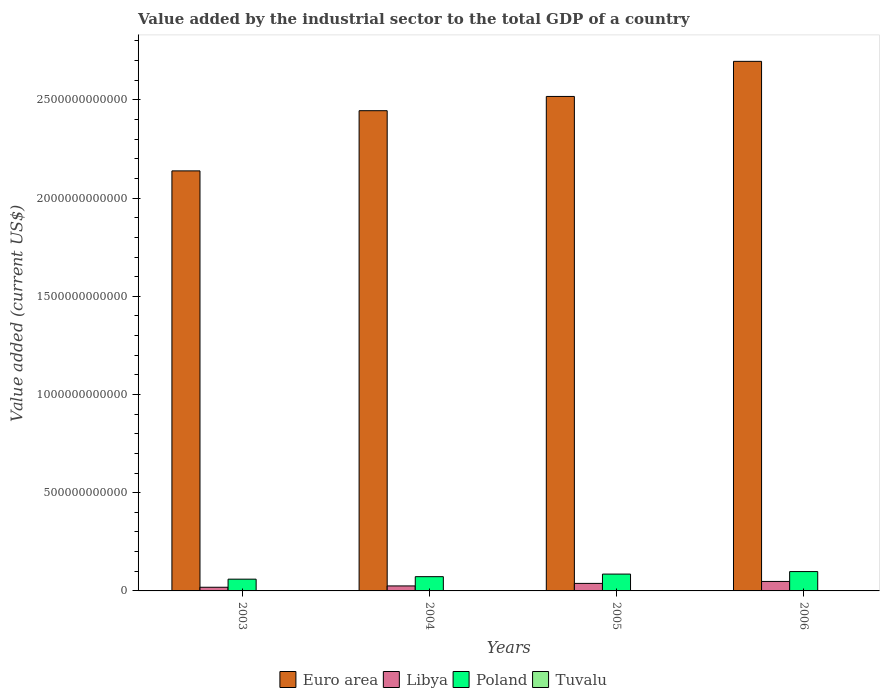How many different coloured bars are there?
Your answer should be very brief. 4. Are the number of bars per tick equal to the number of legend labels?
Give a very brief answer. Yes. How many bars are there on the 2nd tick from the right?
Provide a short and direct response. 4. What is the label of the 1st group of bars from the left?
Make the answer very short. 2003. What is the value added by the industrial sector to the total GDP in Poland in 2004?
Make the answer very short. 7.26e+1. Across all years, what is the maximum value added by the industrial sector to the total GDP in Tuvalu?
Offer a terse response. 2.05e+06. Across all years, what is the minimum value added by the industrial sector to the total GDP in Euro area?
Make the answer very short. 2.14e+12. What is the total value added by the industrial sector to the total GDP in Libya in the graph?
Make the answer very short. 1.31e+11. What is the difference between the value added by the industrial sector to the total GDP in Tuvalu in 2005 and that in 2006?
Offer a terse response. 3.97e+05. What is the difference between the value added by the industrial sector to the total GDP in Euro area in 2003 and the value added by the industrial sector to the total GDP in Poland in 2006?
Make the answer very short. 2.04e+12. What is the average value added by the industrial sector to the total GDP in Libya per year?
Your response must be concise. 3.26e+1. In the year 2006, what is the difference between the value added by the industrial sector to the total GDP in Libya and value added by the industrial sector to the total GDP in Tuvalu?
Your response must be concise. 4.83e+1. In how many years, is the value added by the industrial sector to the total GDP in Tuvalu greater than 1200000000000 US$?
Keep it short and to the point. 0. What is the ratio of the value added by the industrial sector to the total GDP in Libya in 2005 to that in 2006?
Make the answer very short. 0.79. Is the value added by the industrial sector to the total GDP in Tuvalu in 2004 less than that in 2005?
Offer a terse response. No. Is the difference between the value added by the industrial sector to the total GDP in Libya in 2003 and 2005 greater than the difference between the value added by the industrial sector to the total GDP in Tuvalu in 2003 and 2005?
Your response must be concise. No. What is the difference between the highest and the second highest value added by the industrial sector to the total GDP in Poland?
Provide a succinct answer. 1.28e+1. What is the difference between the highest and the lowest value added by the industrial sector to the total GDP in Libya?
Keep it short and to the point. 2.96e+1. In how many years, is the value added by the industrial sector to the total GDP in Tuvalu greater than the average value added by the industrial sector to the total GDP in Tuvalu taken over all years?
Give a very brief answer. 2. What does the 2nd bar from the left in 2005 represents?
Ensure brevity in your answer.  Libya. Is it the case that in every year, the sum of the value added by the industrial sector to the total GDP in Euro area and value added by the industrial sector to the total GDP in Poland is greater than the value added by the industrial sector to the total GDP in Libya?
Offer a very short reply. Yes. How many bars are there?
Keep it short and to the point. 16. Are all the bars in the graph horizontal?
Give a very brief answer. No. How many years are there in the graph?
Offer a very short reply. 4. What is the difference between two consecutive major ticks on the Y-axis?
Make the answer very short. 5.00e+11. Are the values on the major ticks of Y-axis written in scientific E-notation?
Your response must be concise. No. How are the legend labels stacked?
Make the answer very short. Horizontal. What is the title of the graph?
Your answer should be very brief. Value added by the industrial sector to the total GDP of a country. What is the label or title of the Y-axis?
Give a very brief answer. Value added (current US$). What is the Value added (current US$) of Euro area in 2003?
Offer a very short reply. 2.14e+12. What is the Value added (current US$) in Libya in 2003?
Give a very brief answer. 1.86e+1. What is the Value added (current US$) of Poland in 2003?
Provide a succinct answer. 5.99e+1. What is the Value added (current US$) of Tuvalu in 2003?
Make the answer very short. 1.86e+06. What is the Value added (current US$) of Euro area in 2004?
Provide a succinct answer. 2.44e+12. What is the Value added (current US$) in Libya in 2004?
Offer a terse response. 2.54e+1. What is the Value added (current US$) in Poland in 2004?
Keep it short and to the point. 7.26e+1. What is the Value added (current US$) of Tuvalu in 2004?
Your answer should be compact. 2.05e+06. What is the Value added (current US$) of Euro area in 2005?
Ensure brevity in your answer.  2.52e+12. What is the Value added (current US$) of Libya in 2005?
Your answer should be very brief. 3.83e+1. What is the Value added (current US$) in Poland in 2005?
Ensure brevity in your answer.  8.57e+1. What is the Value added (current US$) of Tuvalu in 2005?
Your answer should be compact. 1.70e+06. What is the Value added (current US$) in Euro area in 2006?
Offer a terse response. 2.70e+12. What is the Value added (current US$) of Libya in 2006?
Provide a succinct answer. 4.83e+1. What is the Value added (current US$) of Poland in 2006?
Provide a short and direct response. 9.85e+1. What is the Value added (current US$) in Tuvalu in 2006?
Provide a short and direct response. 1.30e+06. Across all years, what is the maximum Value added (current US$) in Euro area?
Your response must be concise. 2.70e+12. Across all years, what is the maximum Value added (current US$) of Libya?
Offer a very short reply. 4.83e+1. Across all years, what is the maximum Value added (current US$) of Poland?
Your answer should be very brief. 9.85e+1. Across all years, what is the maximum Value added (current US$) in Tuvalu?
Your answer should be compact. 2.05e+06. Across all years, what is the minimum Value added (current US$) of Euro area?
Provide a succinct answer. 2.14e+12. Across all years, what is the minimum Value added (current US$) of Libya?
Provide a short and direct response. 1.86e+1. Across all years, what is the minimum Value added (current US$) of Poland?
Your response must be concise. 5.99e+1. Across all years, what is the minimum Value added (current US$) of Tuvalu?
Your answer should be very brief. 1.30e+06. What is the total Value added (current US$) of Euro area in the graph?
Keep it short and to the point. 9.80e+12. What is the total Value added (current US$) of Libya in the graph?
Ensure brevity in your answer.  1.31e+11. What is the total Value added (current US$) of Poland in the graph?
Your response must be concise. 3.17e+11. What is the total Value added (current US$) of Tuvalu in the graph?
Keep it short and to the point. 6.91e+06. What is the difference between the Value added (current US$) in Euro area in 2003 and that in 2004?
Provide a succinct answer. -3.06e+11. What is the difference between the Value added (current US$) in Libya in 2003 and that in 2004?
Offer a terse response. -6.77e+09. What is the difference between the Value added (current US$) of Poland in 2003 and that in 2004?
Make the answer very short. -1.27e+1. What is the difference between the Value added (current US$) in Tuvalu in 2003 and that in 2004?
Keep it short and to the point. -1.95e+05. What is the difference between the Value added (current US$) of Euro area in 2003 and that in 2005?
Your answer should be very brief. -3.79e+11. What is the difference between the Value added (current US$) of Libya in 2003 and that in 2005?
Your response must be concise. -1.97e+1. What is the difference between the Value added (current US$) in Poland in 2003 and that in 2005?
Your answer should be compact. -2.59e+1. What is the difference between the Value added (current US$) of Tuvalu in 2003 and that in 2005?
Your answer should be very brief. 1.57e+05. What is the difference between the Value added (current US$) of Euro area in 2003 and that in 2006?
Provide a succinct answer. -5.58e+11. What is the difference between the Value added (current US$) of Libya in 2003 and that in 2006?
Keep it short and to the point. -2.96e+1. What is the difference between the Value added (current US$) of Poland in 2003 and that in 2006?
Make the answer very short. -3.86e+1. What is the difference between the Value added (current US$) in Tuvalu in 2003 and that in 2006?
Provide a short and direct response. 5.54e+05. What is the difference between the Value added (current US$) of Euro area in 2004 and that in 2005?
Provide a succinct answer. -7.26e+1. What is the difference between the Value added (current US$) of Libya in 2004 and that in 2005?
Your answer should be compact. -1.29e+1. What is the difference between the Value added (current US$) of Poland in 2004 and that in 2005?
Make the answer very short. -1.32e+1. What is the difference between the Value added (current US$) of Tuvalu in 2004 and that in 2005?
Your answer should be very brief. 3.52e+05. What is the difference between the Value added (current US$) of Euro area in 2004 and that in 2006?
Provide a short and direct response. -2.51e+11. What is the difference between the Value added (current US$) of Libya in 2004 and that in 2006?
Provide a short and direct response. -2.29e+1. What is the difference between the Value added (current US$) in Poland in 2004 and that in 2006?
Make the answer very short. -2.59e+1. What is the difference between the Value added (current US$) in Tuvalu in 2004 and that in 2006?
Keep it short and to the point. 7.49e+05. What is the difference between the Value added (current US$) in Euro area in 2005 and that in 2006?
Provide a short and direct response. -1.79e+11. What is the difference between the Value added (current US$) in Libya in 2005 and that in 2006?
Ensure brevity in your answer.  -9.93e+09. What is the difference between the Value added (current US$) of Poland in 2005 and that in 2006?
Ensure brevity in your answer.  -1.28e+1. What is the difference between the Value added (current US$) of Tuvalu in 2005 and that in 2006?
Make the answer very short. 3.97e+05. What is the difference between the Value added (current US$) of Euro area in 2003 and the Value added (current US$) of Libya in 2004?
Offer a terse response. 2.11e+12. What is the difference between the Value added (current US$) of Euro area in 2003 and the Value added (current US$) of Poland in 2004?
Give a very brief answer. 2.07e+12. What is the difference between the Value added (current US$) of Euro area in 2003 and the Value added (current US$) of Tuvalu in 2004?
Your response must be concise. 2.14e+12. What is the difference between the Value added (current US$) in Libya in 2003 and the Value added (current US$) in Poland in 2004?
Your answer should be very brief. -5.40e+1. What is the difference between the Value added (current US$) in Libya in 2003 and the Value added (current US$) in Tuvalu in 2004?
Your response must be concise. 1.86e+1. What is the difference between the Value added (current US$) of Poland in 2003 and the Value added (current US$) of Tuvalu in 2004?
Keep it short and to the point. 5.99e+1. What is the difference between the Value added (current US$) of Euro area in 2003 and the Value added (current US$) of Libya in 2005?
Keep it short and to the point. 2.10e+12. What is the difference between the Value added (current US$) of Euro area in 2003 and the Value added (current US$) of Poland in 2005?
Your response must be concise. 2.05e+12. What is the difference between the Value added (current US$) in Euro area in 2003 and the Value added (current US$) in Tuvalu in 2005?
Your answer should be compact. 2.14e+12. What is the difference between the Value added (current US$) in Libya in 2003 and the Value added (current US$) in Poland in 2005?
Ensure brevity in your answer.  -6.71e+1. What is the difference between the Value added (current US$) in Libya in 2003 and the Value added (current US$) in Tuvalu in 2005?
Make the answer very short. 1.86e+1. What is the difference between the Value added (current US$) of Poland in 2003 and the Value added (current US$) of Tuvalu in 2005?
Offer a very short reply. 5.99e+1. What is the difference between the Value added (current US$) in Euro area in 2003 and the Value added (current US$) in Libya in 2006?
Your answer should be compact. 2.09e+12. What is the difference between the Value added (current US$) of Euro area in 2003 and the Value added (current US$) of Poland in 2006?
Make the answer very short. 2.04e+12. What is the difference between the Value added (current US$) of Euro area in 2003 and the Value added (current US$) of Tuvalu in 2006?
Your response must be concise. 2.14e+12. What is the difference between the Value added (current US$) of Libya in 2003 and the Value added (current US$) of Poland in 2006?
Provide a succinct answer. -7.99e+1. What is the difference between the Value added (current US$) of Libya in 2003 and the Value added (current US$) of Tuvalu in 2006?
Ensure brevity in your answer.  1.86e+1. What is the difference between the Value added (current US$) in Poland in 2003 and the Value added (current US$) in Tuvalu in 2006?
Provide a short and direct response. 5.99e+1. What is the difference between the Value added (current US$) in Euro area in 2004 and the Value added (current US$) in Libya in 2005?
Keep it short and to the point. 2.41e+12. What is the difference between the Value added (current US$) of Euro area in 2004 and the Value added (current US$) of Poland in 2005?
Ensure brevity in your answer.  2.36e+12. What is the difference between the Value added (current US$) of Euro area in 2004 and the Value added (current US$) of Tuvalu in 2005?
Provide a succinct answer. 2.44e+12. What is the difference between the Value added (current US$) of Libya in 2004 and the Value added (current US$) of Poland in 2005?
Keep it short and to the point. -6.04e+1. What is the difference between the Value added (current US$) of Libya in 2004 and the Value added (current US$) of Tuvalu in 2005?
Provide a succinct answer. 2.54e+1. What is the difference between the Value added (current US$) in Poland in 2004 and the Value added (current US$) in Tuvalu in 2005?
Keep it short and to the point. 7.26e+1. What is the difference between the Value added (current US$) in Euro area in 2004 and the Value added (current US$) in Libya in 2006?
Keep it short and to the point. 2.40e+12. What is the difference between the Value added (current US$) of Euro area in 2004 and the Value added (current US$) of Poland in 2006?
Ensure brevity in your answer.  2.35e+12. What is the difference between the Value added (current US$) of Euro area in 2004 and the Value added (current US$) of Tuvalu in 2006?
Provide a short and direct response. 2.44e+12. What is the difference between the Value added (current US$) in Libya in 2004 and the Value added (current US$) in Poland in 2006?
Provide a succinct answer. -7.31e+1. What is the difference between the Value added (current US$) in Libya in 2004 and the Value added (current US$) in Tuvalu in 2006?
Give a very brief answer. 2.54e+1. What is the difference between the Value added (current US$) in Poland in 2004 and the Value added (current US$) in Tuvalu in 2006?
Your answer should be compact. 7.26e+1. What is the difference between the Value added (current US$) of Euro area in 2005 and the Value added (current US$) of Libya in 2006?
Give a very brief answer. 2.47e+12. What is the difference between the Value added (current US$) of Euro area in 2005 and the Value added (current US$) of Poland in 2006?
Your answer should be compact. 2.42e+12. What is the difference between the Value added (current US$) in Euro area in 2005 and the Value added (current US$) in Tuvalu in 2006?
Offer a terse response. 2.52e+12. What is the difference between the Value added (current US$) of Libya in 2005 and the Value added (current US$) of Poland in 2006?
Offer a very short reply. -6.02e+1. What is the difference between the Value added (current US$) in Libya in 2005 and the Value added (current US$) in Tuvalu in 2006?
Provide a succinct answer. 3.83e+1. What is the difference between the Value added (current US$) of Poland in 2005 and the Value added (current US$) of Tuvalu in 2006?
Provide a short and direct response. 8.57e+1. What is the average Value added (current US$) of Euro area per year?
Your response must be concise. 2.45e+12. What is the average Value added (current US$) in Libya per year?
Offer a terse response. 3.26e+1. What is the average Value added (current US$) of Poland per year?
Offer a terse response. 7.92e+1. What is the average Value added (current US$) of Tuvalu per year?
Provide a succinct answer. 1.73e+06. In the year 2003, what is the difference between the Value added (current US$) of Euro area and Value added (current US$) of Libya?
Offer a very short reply. 2.12e+12. In the year 2003, what is the difference between the Value added (current US$) in Euro area and Value added (current US$) in Poland?
Provide a succinct answer. 2.08e+12. In the year 2003, what is the difference between the Value added (current US$) of Euro area and Value added (current US$) of Tuvalu?
Offer a terse response. 2.14e+12. In the year 2003, what is the difference between the Value added (current US$) of Libya and Value added (current US$) of Poland?
Give a very brief answer. -4.12e+1. In the year 2003, what is the difference between the Value added (current US$) in Libya and Value added (current US$) in Tuvalu?
Make the answer very short. 1.86e+1. In the year 2003, what is the difference between the Value added (current US$) in Poland and Value added (current US$) in Tuvalu?
Keep it short and to the point. 5.99e+1. In the year 2004, what is the difference between the Value added (current US$) of Euro area and Value added (current US$) of Libya?
Keep it short and to the point. 2.42e+12. In the year 2004, what is the difference between the Value added (current US$) of Euro area and Value added (current US$) of Poland?
Offer a very short reply. 2.37e+12. In the year 2004, what is the difference between the Value added (current US$) of Euro area and Value added (current US$) of Tuvalu?
Provide a succinct answer. 2.44e+12. In the year 2004, what is the difference between the Value added (current US$) in Libya and Value added (current US$) in Poland?
Ensure brevity in your answer.  -4.72e+1. In the year 2004, what is the difference between the Value added (current US$) of Libya and Value added (current US$) of Tuvalu?
Provide a succinct answer. 2.54e+1. In the year 2004, what is the difference between the Value added (current US$) in Poland and Value added (current US$) in Tuvalu?
Give a very brief answer. 7.26e+1. In the year 2005, what is the difference between the Value added (current US$) of Euro area and Value added (current US$) of Libya?
Offer a terse response. 2.48e+12. In the year 2005, what is the difference between the Value added (current US$) in Euro area and Value added (current US$) in Poland?
Keep it short and to the point. 2.43e+12. In the year 2005, what is the difference between the Value added (current US$) in Euro area and Value added (current US$) in Tuvalu?
Make the answer very short. 2.52e+12. In the year 2005, what is the difference between the Value added (current US$) in Libya and Value added (current US$) in Poland?
Your answer should be very brief. -4.74e+1. In the year 2005, what is the difference between the Value added (current US$) of Libya and Value added (current US$) of Tuvalu?
Your answer should be compact. 3.83e+1. In the year 2005, what is the difference between the Value added (current US$) in Poland and Value added (current US$) in Tuvalu?
Provide a succinct answer. 8.57e+1. In the year 2006, what is the difference between the Value added (current US$) of Euro area and Value added (current US$) of Libya?
Provide a succinct answer. 2.65e+12. In the year 2006, what is the difference between the Value added (current US$) of Euro area and Value added (current US$) of Poland?
Give a very brief answer. 2.60e+12. In the year 2006, what is the difference between the Value added (current US$) of Euro area and Value added (current US$) of Tuvalu?
Offer a terse response. 2.70e+12. In the year 2006, what is the difference between the Value added (current US$) in Libya and Value added (current US$) in Poland?
Keep it short and to the point. -5.03e+1. In the year 2006, what is the difference between the Value added (current US$) of Libya and Value added (current US$) of Tuvalu?
Give a very brief answer. 4.83e+1. In the year 2006, what is the difference between the Value added (current US$) in Poland and Value added (current US$) in Tuvalu?
Give a very brief answer. 9.85e+1. What is the ratio of the Value added (current US$) in Euro area in 2003 to that in 2004?
Your answer should be very brief. 0.87. What is the ratio of the Value added (current US$) in Libya in 2003 to that in 2004?
Offer a terse response. 0.73. What is the ratio of the Value added (current US$) in Poland in 2003 to that in 2004?
Provide a short and direct response. 0.82. What is the ratio of the Value added (current US$) of Tuvalu in 2003 to that in 2004?
Provide a succinct answer. 0.91. What is the ratio of the Value added (current US$) of Euro area in 2003 to that in 2005?
Your response must be concise. 0.85. What is the ratio of the Value added (current US$) of Libya in 2003 to that in 2005?
Provide a succinct answer. 0.49. What is the ratio of the Value added (current US$) of Poland in 2003 to that in 2005?
Make the answer very short. 0.7. What is the ratio of the Value added (current US$) in Tuvalu in 2003 to that in 2005?
Your answer should be very brief. 1.09. What is the ratio of the Value added (current US$) in Euro area in 2003 to that in 2006?
Keep it short and to the point. 0.79. What is the ratio of the Value added (current US$) in Libya in 2003 to that in 2006?
Offer a terse response. 0.39. What is the ratio of the Value added (current US$) in Poland in 2003 to that in 2006?
Give a very brief answer. 0.61. What is the ratio of the Value added (current US$) of Tuvalu in 2003 to that in 2006?
Your response must be concise. 1.43. What is the ratio of the Value added (current US$) in Euro area in 2004 to that in 2005?
Ensure brevity in your answer.  0.97. What is the ratio of the Value added (current US$) in Libya in 2004 to that in 2005?
Offer a terse response. 0.66. What is the ratio of the Value added (current US$) of Poland in 2004 to that in 2005?
Keep it short and to the point. 0.85. What is the ratio of the Value added (current US$) of Tuvalu in 2004 to that in 2005?
Give a very brief answer. 1.21. What is the ratio of the Value added (current US$) in Euro area in 2004 to that in 2006?
Offer a terse response. 0.91. What is the ratio of the Value added (current US$) in Libya in 2004 to that in 2006?
Make the answer very short. 0.53. What is the ratio of the Value added (current US$) of Poland in 2004 to that in 2006?
Provide a short and direct response. 0.74. What is the ratio of the Value added (current US$) of Tuvalu in 2004 to that in 2006?
Offer a very short reply. 1.58. What is the ratio of the Value added (current US$) of Euro area in 2005 to that in 2006?
Make the answer very short. 0.93. What is the ratio of the Value added (current US$) of Libya in 2005 to that in 2006?
Ensure brevity in your answer.  0.79. What is the ratio of the Value added (current US$) in Poland in 2005 to that in 2006?
Your answer should be very brief. 0.87. What is the ratio of the Value added (current US$) in Tuvalu in 2005 to that in 2006?
Offer a terse response. 1.31. What is the difference between the highest and the second highest Value added (current US$) of Euro area?
Offer a terse response. 1.79e+11. What is the difference between the highest and the second highest Value added (current US$) of Libya?
Your answer should be very brief. 9.93e+09. What is the difference between the highest and the second highest Value added (current US$) of Poland?
Your answer should be very brief. 1.28e+1. What is the difference between the highest and the second highest Value added (current US$) in Tuvalu?
Your answer should be compact. 1.95e+05. What is the difference between the highest and the lowest Value added (current US$) in Euro area?
Your response must be concise. 5.58e+11. What is the difference between the highest and the lowest Value added (current US$) of Libya?
Offer a terse response. 2.96e+1. What is the difference between the highest and the lowest Value added (current US$) of Poland?
Offer a very short reply. 3.86e+1. What is the difference between the highest and the lowest Value added (current US$) in Tuvalu?
Make the answer very short. 7.49e+05. 